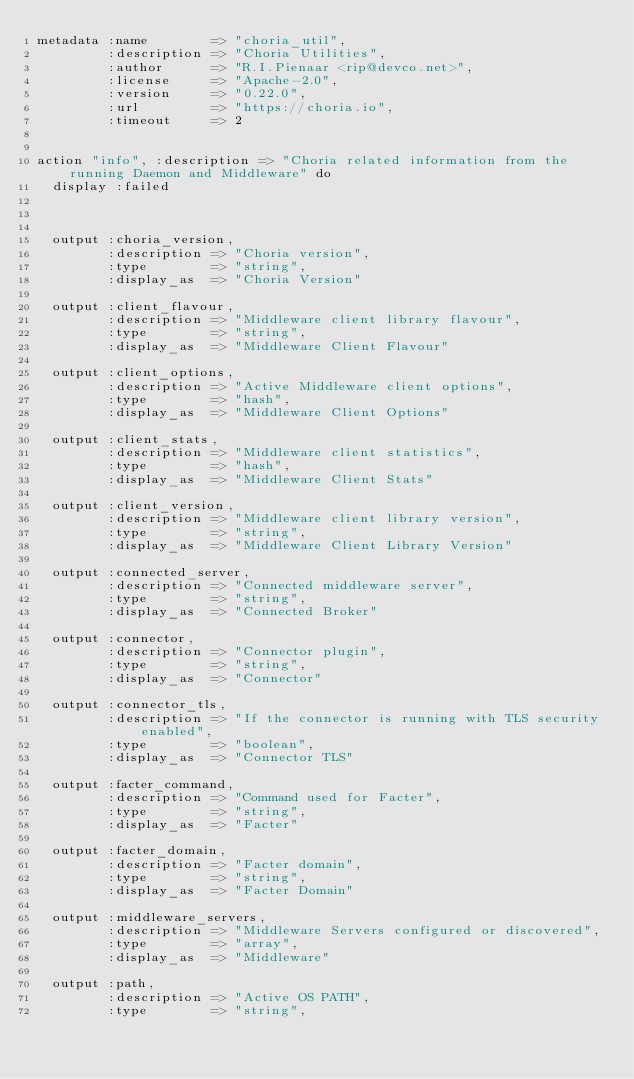<code> <loc_0><loc_0><loc_500><loc_500><_SQL_>metadata :name        => "choria_util",
         :description => "Choria Utilities",
         :author      => "R.I.Pienaar <rip@devco.net>",
         :license     => "Apache-2.0",
         :version     => "0.22.0",
         :url         => "https://choria.io",
         :timeout     => 2


action "info", :description => "Choria related information from the running Daemon and Middleware" do
  display :failed



  output :choria_version,
         :description => "Choria version",
         :type        => "string",
         :display_as  => "Choria Version"

  output :client_flavour,
         :description => "Middleware client library flavour",
         :type        => "string",
         :display_as  => "Middleware Client Flavour"

  output :client_options,
         :description => "Active Middleware client options",
         :type        => "hash",
         :display_as  => "Middleware Client Options"

  output :client_stats,
         :description => "Middleware client statistics",
         :type        => "hash",
         :display_as  => "Middleware Client Stats"

  output :client_version,
         :description => "Middleware client library version",
         :type        => "string",
         :display_as  => "Middleware Client Library Version"

  output :connected_server,
         :description => "Connected middleware server",
         :type        => "string",
         :display_as  => "Connected Broker"

  output :connector,
         :description => "Connector plugin",
         :type        => "string",
         :display_as  => "Connector"

  output :connector_tls,
         :description => "If the connector is running with TLS security enabled",
         :type        => "boolean",
         :display_as  => "Connector TLS"

  output :facter_command,
         :description => "Command used for Facter",
         :type        => "string",
         :display_as  => "Facter"

  output :facter_domain,
         :description => "Facter domain",
         :type        => "string",
         :display_as  => "Facter Domain"

  output :middleware_servers,
         :description => "Middleware Servers configured or discovered",
         :type        => "array",
         :display_as  => "Middleware"

  output :path,
         :description => "Active OS PATH",
         :type        => "string",</code> 